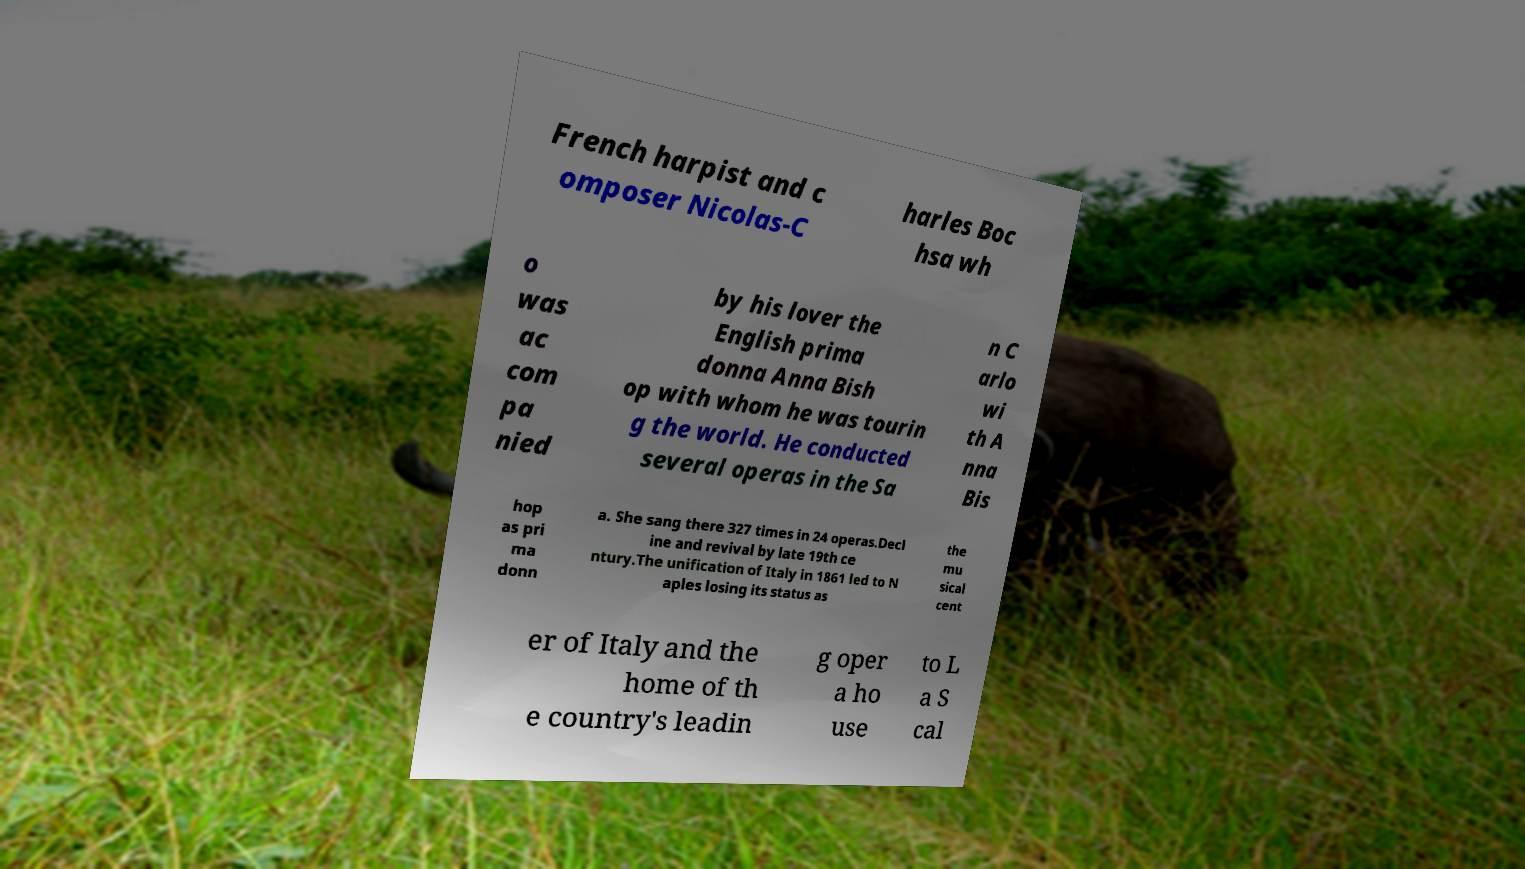I need the written content from this picture converted into text. Can you do that? French harpist and c omposer Nicolas-C harles Boc hsa wh o was ac com pa nied by his lover the English prima donna Anna Bish op with whom he was tourin g the world. He conducted several operas in the Sa n C arlo wi th A nna Bis hop as pri ma donn a. She sang there 327 times in 24 operas.Decl ine and revival by late 19th ce ntury.The unification of Italy in 1861 led to N aples losing its status as the mu sical cent er of Italy and the home of th e country's leadin g oper a ho use to L a S cal 